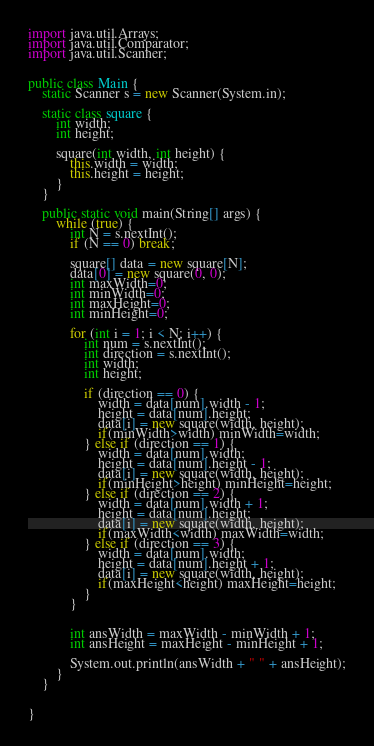<code> <loc_0><loc_0><loc_500><loc_500><_Java_>import java.util.Arrays;
import java.util.Comparator;
import java.util.Scanner;


public class Main {
    static Scanner s = new Scanner(System.in);

    static class square {
        int width;
        int height;
        
        square(int width, int height) {
            this.width = width;
            this.height = height;
        }
    }

    public static void main(String[] args) {
        while (true) {
            int N = s.nextInt();
            if (N == 0) break;

            square[] data = new square[N];
            data[0] = new square(0, 0);
            int maxWidth=0;
            int minWidth=0;
            int maxHeight=0;
            int minHeight=0;

            for (int i = 1; i < N; i++) {
                int num = s.nextInt();
                int direction = s.nextInt();
                int width;
                int height;

                if (direction == 0) {
                    width = data[num].width - 1;
                    height = data[num].height;
                    data[i] = new square(width, height);
                    if(minWidth>width) minWidth=width;
                } else if (direction == 1) {
                    width = data[num].width;
                    height = data[num].height - 1;
                    data[i] = new square(width, height);
                    if(minHeight>height) minHeight=height;
                } else if (direction == 2) {
                    width = data[num].width + 1;
                    height = data[num].height;
                    data[i] = new square(width, height);
                    if(maxWidth<width) maxWidth=width;
                } else if (direction == 3) {
                    width = data[num].width;
                    height = data[num].height + 1;
                    data[i] = new square(width, height);
                    if(maxHeight<height) maxHeight=height;
                }
            }


            int ansWidth = maxWidth - minWidth + 1;
            int ansHeight = maxHeight - minHeight + 1;

            System.out.println(ansWidth + " " + ansHeight);
        }
    }


}</code> 